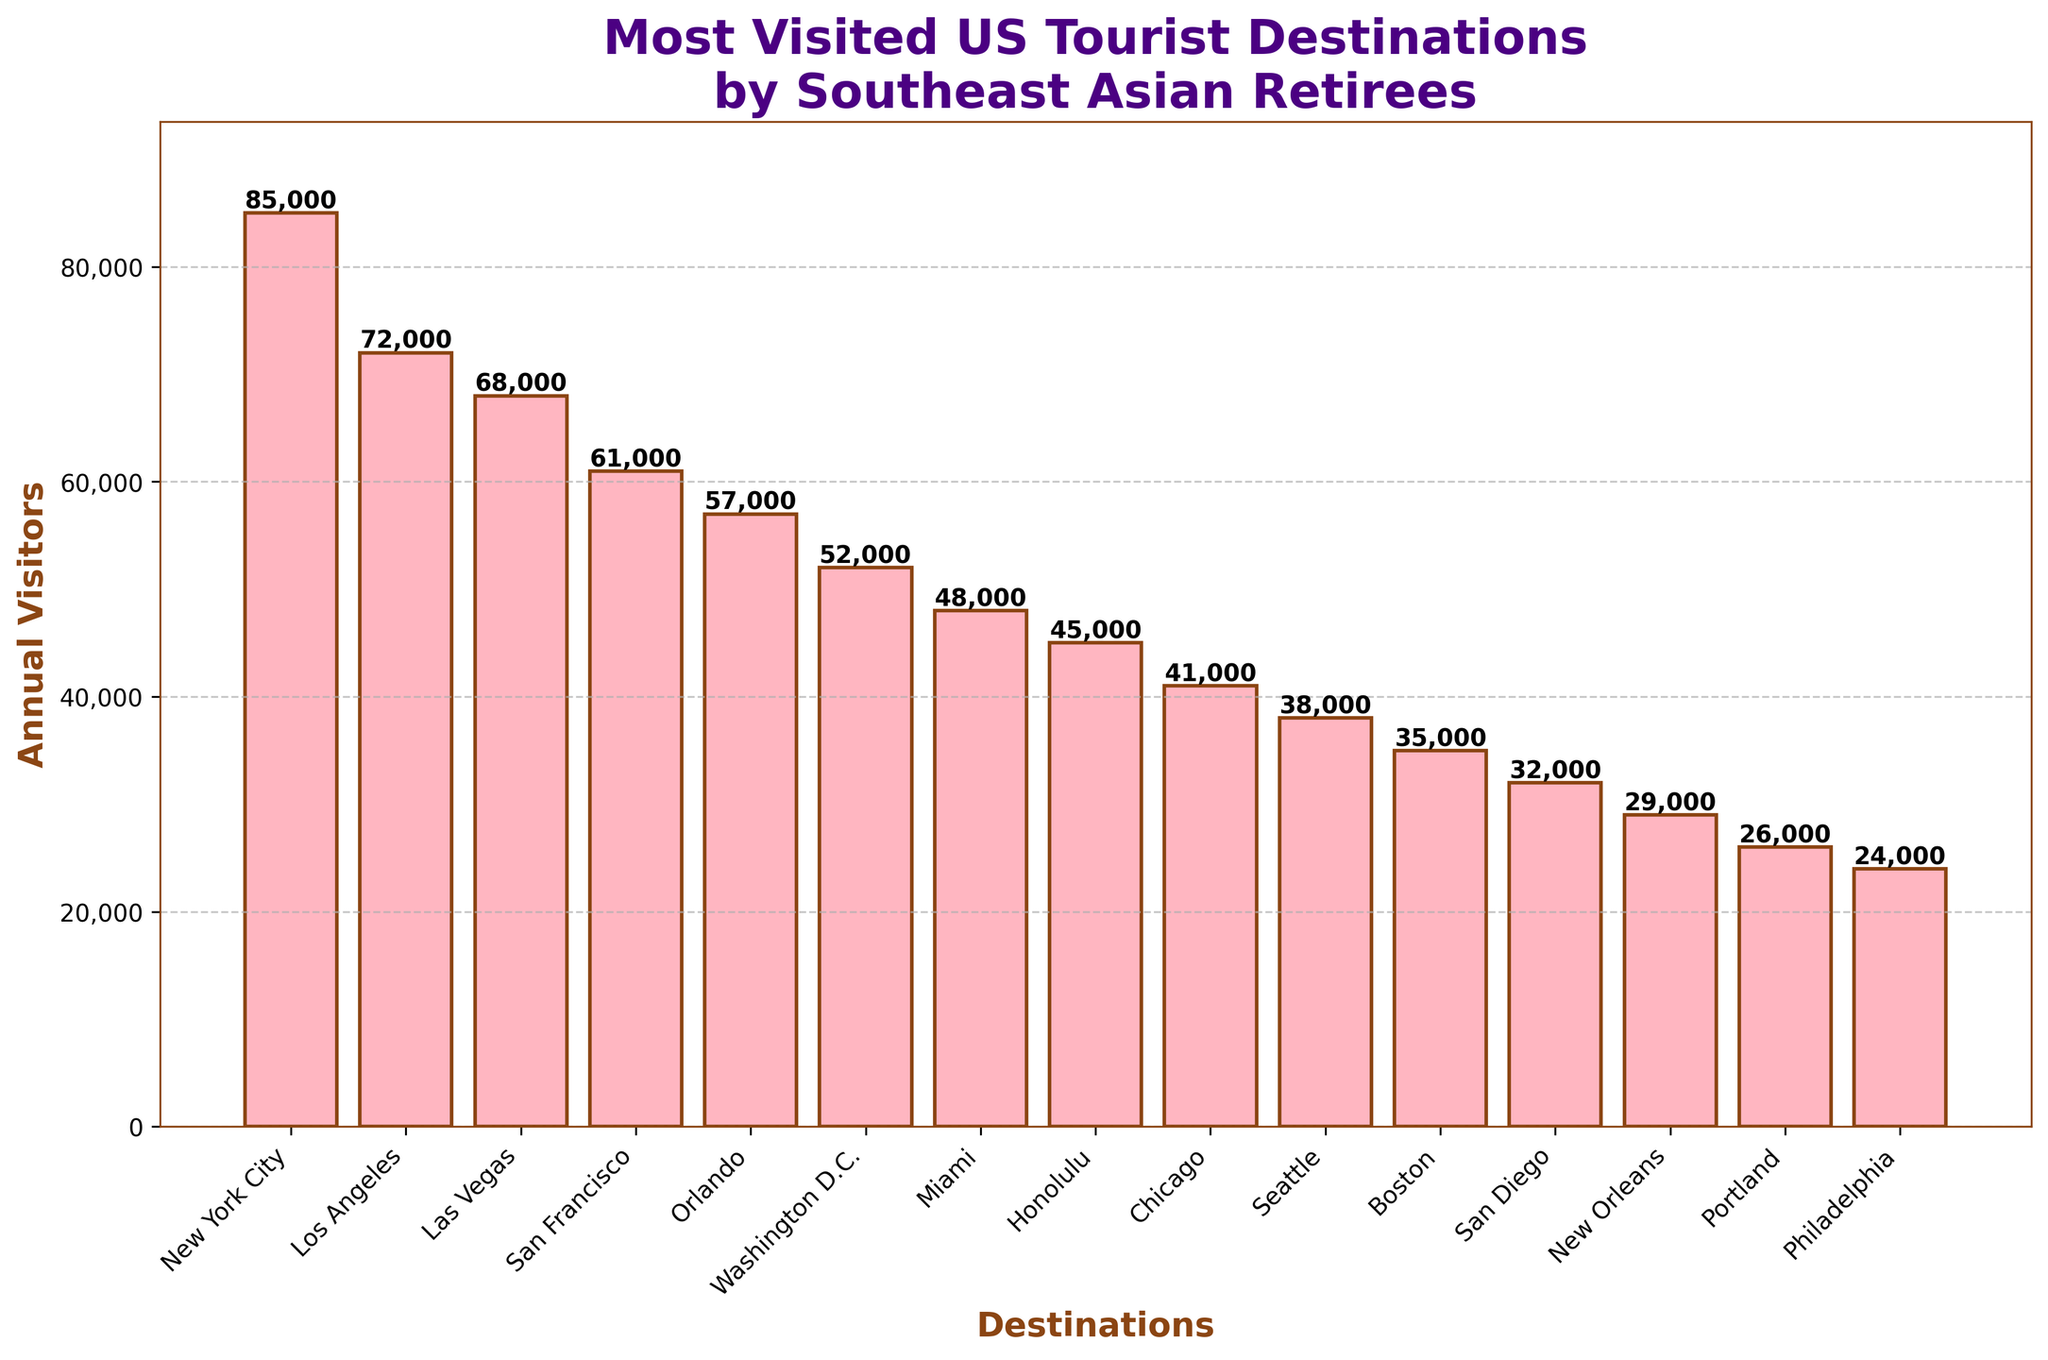Which destination has the highest number of annual visitors? The tallest bar represents New York City with the highest number of annual visitors at 85,000.
Answer: New York City Which destination has the lowest number of annual visitors? The shortest bar represents Philadelphia with the lowest number of annual visitors at 24,000.
Answer: Philadelphia How many more visitors does New York City have compared to Las Vegas? New York City has 85,000 visitors and Las Vegas has 68,000 visitors. The difference is 85,000 - 68,000 = 17,000.
Answer: 17,000 Add the total annual visitors for San Francisco, Orlando, and Miami. San Francisco has 61,000 visitors, Orlando has 57,000, and Miami has 48,000. The sum is 61,000 + 57,000 + 48,000 = 166,000.
Answer: 166,000 Which cities have more visitors than Seattle? Seattle has 38,000 visitors. Cities with more are New York City, Los Angeles, Las Vegas, San Francisco, Orlando, Washington D.C., Miami, Honolulu, and Chicago.
Answer: New York City, Los Angeles, Las Vegas, San Francisco, Orlando, Washington D.C., Miami, Honolulu, Chicago Compare the visitor count of Los Angeles and Honolulu. How many times more visitors does Los Angeles have compared to Honolulu? Los Angeles has 72,000 visitors and Honolulu has 45,000. Los Angeles has 72,000 / 45,000 ≈ 1.6 times more visitors.
Answer: 1.6 times What is the average number of visitors across all destinations? Sum all visitor counts (85000 + 72000 + 68000 + 61000 + 57000 + 52000 + 48000 + 45000 + 41000 + 38000 + 35000 + 32000 + 29000 + 26000 + 24000) = 707,000. With 15 destinations, the average is 707,000 / 15 ≈ 47,133.
Answer: 47,133 Is the number of visitors to Las Vegas greater than the combined visitors to Portland and San Diego? Las Vegas has 68,000 visitors. Portland and San Diego combined have 26,000 + 32,000 = 58,000 visitors. 68,000 > 58,000, so Las Vegas has more.
Answer: Yes 